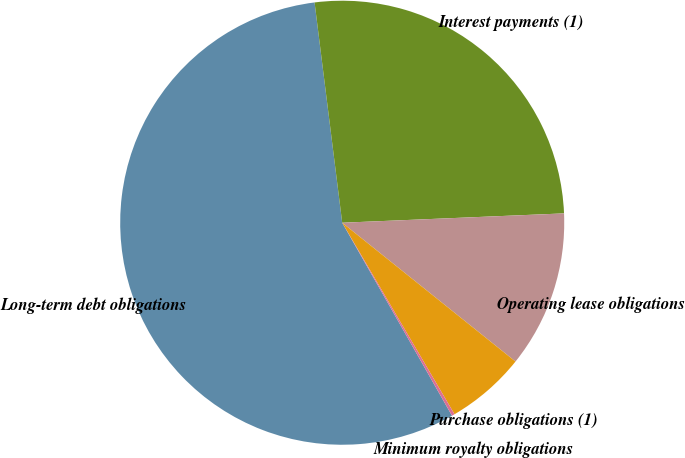Convert chart to OTSL. <chart><loc_0><loc_0><loc_500><loc_500><pie_chart><fcel>Long-term debt obligations<fcel>Interest payments (1)<fcel>Operating lease obligations<fcel>Purchase obligations (1)<fcel>Minimum royalty obligations<nl><fcel>56.25%<fcel>26.32%<fcel>11.42%<fcel>5.81%<fcel>0.21%<nl></chart> 